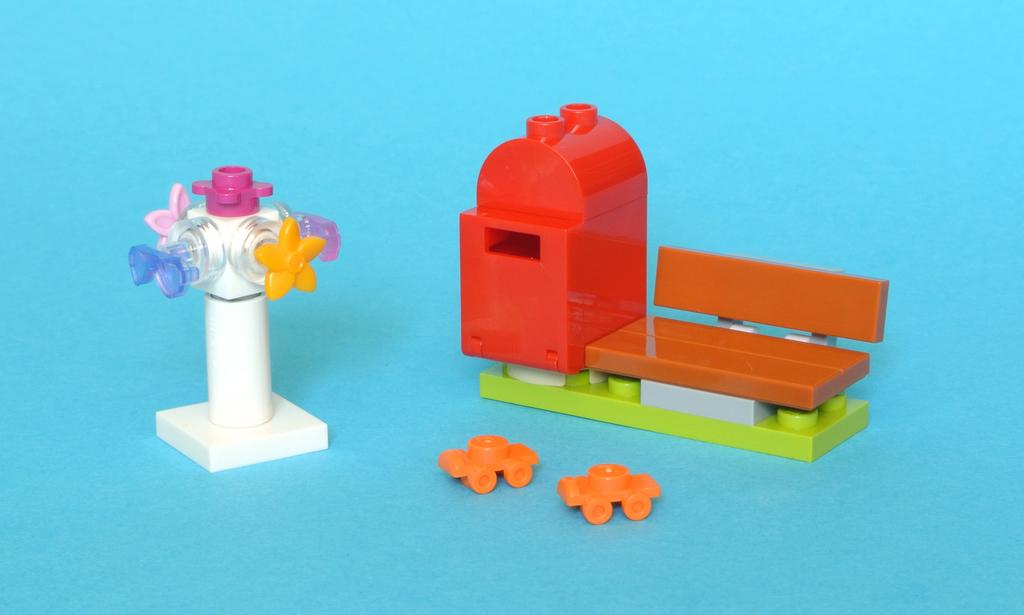What type of toys are visible in the image? There are lego toys in the image. Where are the lego toys located? The lego toys are on an object. What color are the pizzas in the image? There are no pizzas present in the image. 